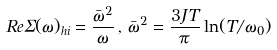<formula> <loc_0><loc_0><loc_500><loc_500>R e \Sigma ( \omega ) _ { h i } = \frac { \bar { \omega } ^ { 2 } } { \omega } \, , \, \bar { \omega } ^ { 2 } = \frac { 3 J T } { \pi } \ln ( T / \omega _ { 0 } )</formula> 